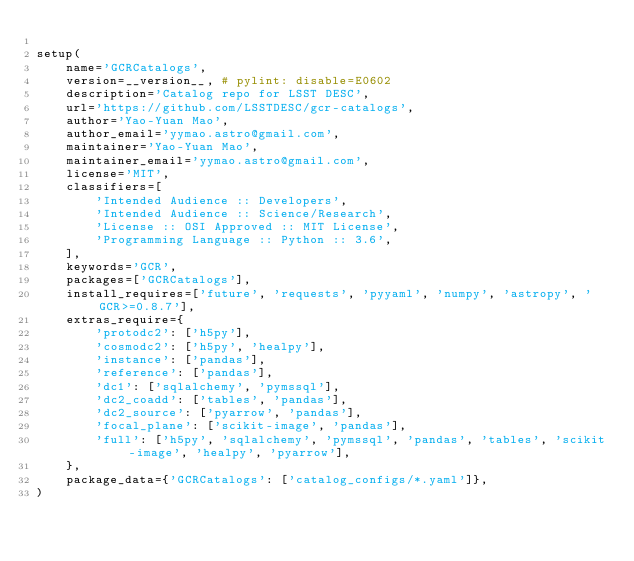<code> <loc_0><loc_0><loc_500><loc_500><_Python_>
setup(
    name='GCRCatalogs',
    version=__version__, # pylint: disable=E0602
    description='Catalog repo for LSST DESC',
    url='https://github.com/LSSTDESC/gcr-catalogs',
    author='Yao-Yuan Mao',
    author_email='yymao.astro@gmail.com',
    maintainer='Yao-Yuan Mao',
    maintainer_email='yymao.astro@gmail.com',
    license='MIT',
    classifiers=[
        'Intended Audience :: Developers',
        'Intended Audience :: Science/Research',
        'License :: OSI Approved :: MIT License',
        'Programming Language :: Python :: 3.6',
    ],
    keywords='GCR',
    packages=['GCRCatalogs'],
    install_requires=['future', 'requests', 'pyyaml', 'numpy', 'astropy', 'GCR>=0.8.7'],
    extras_require={
        'protodc2': ['h5py'],
        'cosmodc2': ['h5py', 'healpy'],
        'instance': ['pandas'],
        'reference': ['pandas'],
        'dc1': ['sqlalchemy', 'pymssql'],
        'dc2_coadd': ['tables', 'pandas'],
        'dc2_source': ['pyarrow', 'pandas'],
        'focal_plane': ['scikit-image', 'pandas'],
        'full': ['h5py', 'sqlalchemy', 'pymssql', 'pandas', 'tables', 'scikit-image', 'healpy', 'pyarrow'],
    },
    package_data={'GCRCatalogs': ['catalog_configs/*.yaml']},
)
</code> 